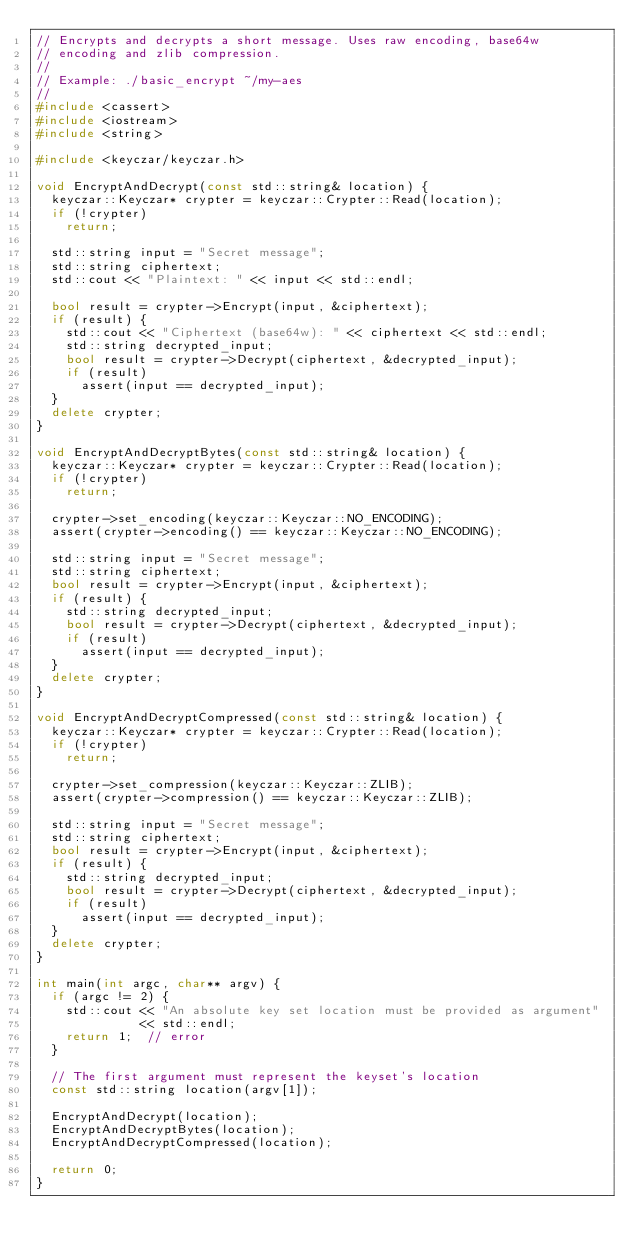Convert code to text. <code><loc_0><loc_0><loc_500><loc_500><_C++_>// Encrypts and decrypts a short message. Uses raw encoding, base64w
// encoding and zlib compression.
//
// Example: ./basic_encrypt ~/my-aes
//
#include <cassert>
#include <iostream>
#include <string>

#include <keyczar/keyczar.h>

void EncryptAndDecrypt(const std::string& location) {
  keyczar::Keyczar* crypter = keyczar::Crypter::Read(location);
  if (!crypter)
    return;

  std::string input = "Secret message";
  std::string ciphertext;
  std::cout << "Plaintext: " << input << std::endl;

  bool result = crypter->Encrypt(input, &ciphertext);
  if (result) {
    std::cout << "Ciphertext (base64w): " << ciphertext << std::endl;
    std::string decrypted_input;
    bool result = crypter->Decrypt(ciphertext, &decrypted_input);
    if (result)
      assert(input == decrypted_input);
  }
  delete crypter;
}

void EncryptAndDecryptBytes(const std::string& location) {
  keyczar::Keyczar* crypter = keyczar::Crypter::Read(location);
  if (!crypter)
    return;

  crypter->set_encoding(keyczar::Keyczar::NO_ENCODING);
  assert(crypter->encoding() == keyczar::Keyczar::NO_ENCODING);

  std::string input = "Secret message";
  std::string ciphertext;
  bool result = crypter->Encrypt(input, &ciphertext);
  if (result) {
    std::string decrypted_input;
    bool result = crypter->Decrypt(ciphertext, &decrypted_input);
    if (result)
      assert(input == decrypted_input);
  }
  delete crypter;
}

void EncryptAndDecryptCompressed(const std::string& location) {
  keyczar::Keyczar* crypter = keyczar::Crypter::Read(location);
  if (!crypter)
    return;

  crypter->set_compression(keyczar::Keyczar::ZLIB);
  assert(crypter->compression() == keyczar::Keyczar::ZLIB);

  std::string input = "Secret message";
  std::string ciphertext;
  bool result = crypter->Encrypt(input, &ciphertext);
  if (result) {
    std::string decrypted_input;
    bool result = crypter->Decrypt(ciphertext, &decrypted_input);
    if (result)
      assert(input == decrypted_input);
  }
  delete crypter;
}

int main(int argc, char** argv) {
  if (argc != 2) {
    std::cout << "An absolute key set location must be provided as argument"
              << std::endl;
    return 1;  // error
  }

  // The first argument must represent the keyset's location
  const std::string location(argv[1]);

  EncryptAndDecrypt(location);
  EncryptAndDecryptBytes(location);
  EncryptAndDecryptCompressed(location);

  return 0;
}
</code> 